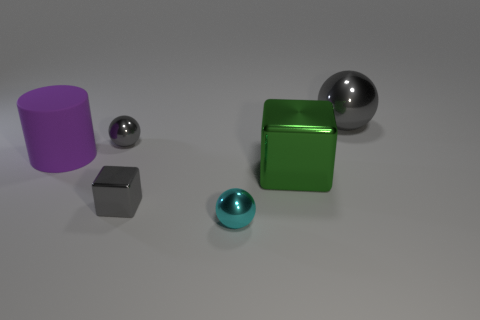There is a gray ball that is to the left of the gray object right of the small gray shiny cube; what is its material?
Offer a very short reply. Metal. Is there a gray metal sphere of the same size as the rubber object?
Your answer should be very brief. Yes. How many objects are gray things that are to the left of the tiny cyan metal thing or metallic things that are right of the green block?
Offer a very short reply. 3. Does the gray ball that is to the left of the cyan object have the same size as the shiny cube that is left of the tiny cyan metal object?
Your answer should be very brief. Yes. Are there any tiny gray objects behind the green shiny thing to the left of the big gray shiny ball?
Provide a short and direct response. Yes. There is a large gray metal object; what number of large rubber cylinders are behind it?
Provide a short and direct response. 0. What number of other objects are the same color as the large shiny sphere?
Provide a short and direct response. 2. Is the number of metallic spheres in front of the small cyan sphere less than the number of large metallic balls on the right side of the tiny gray metallic cube?
Your answer should be compact. Yes. What number of objects are large objects that are in front of the tiny gray metal ball or gray metallic cubes?
Make the answer very short. 3. There is a purple matte thing; is its size the same as the shiny sphere in front of the small gray cube?
Your response must be concise. No. 